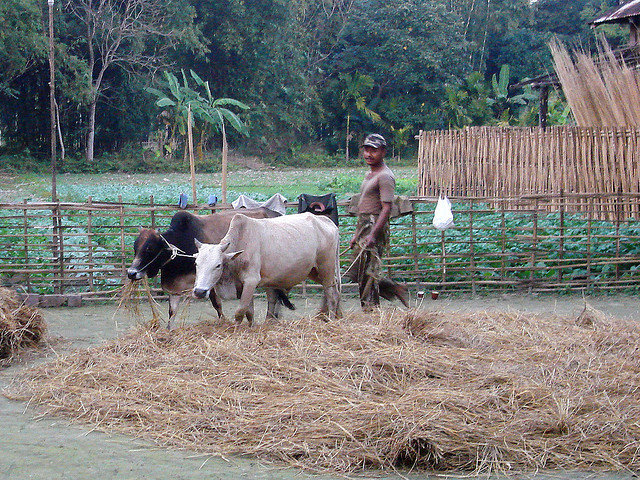What might be the role of the individual standing behind the cattle? The individual appears to be a herdsman, whose role is likely to care for and manage the cattle. He might be supervising their feeding, ensuring they are safe, and possibly preparing to lead them elsewhere. His attire suggests he works outdoors and is dressed for practicality, indicating that his tasks could include a range of activities associated with cattle farming. 